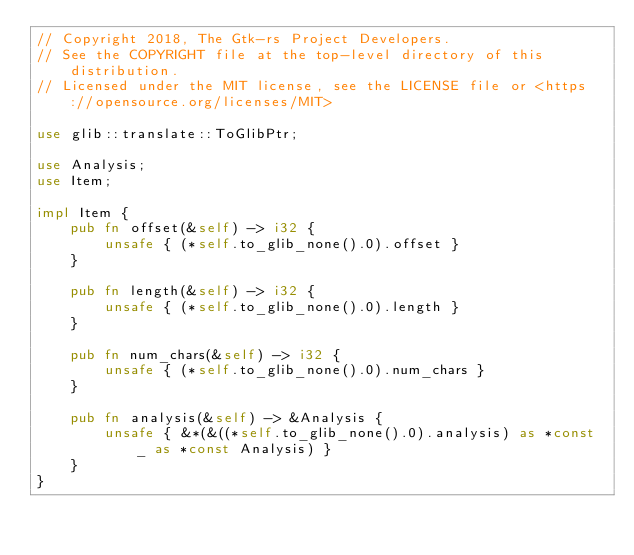Convert code to text. <code><loc_0><loc_0><loc_500><loc_500><_Rust_>// Copyright 2018, The Gtk-rs Project Developers.
// See the COPYRIGHT file at the top-level directory of this distribution.
// Licensed under the MIT license, see the LICENSE file or <https://opensource.org/licenses/MIT>

use glib::translate::ToGlibPtr;

use Analysis;
use Item;

impl Item {
    pub fn offset(&self) -> i32 {
        unsafe { (*self.to_glib_none().0).offset }
    }

    pub fn length(&self) -> i32 {
        unsafe { (*self.to_glib_none().0).length }
    }

    pub fn num_chars(&self) -> i32 {
        unsafe { (*self.to_glib_none().0).num_chars }
    }

    pub fn analysis(&self) -> &Analysis {
        unsafe { &*(&((*self.to_glib_none().0).analysis) as *const _ as *const Analysis) }
    }
}
</code> 